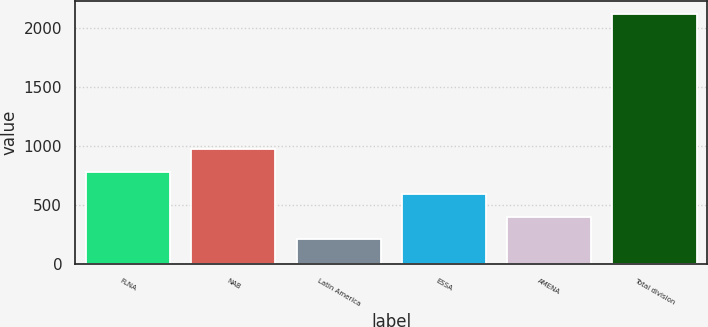Convert chart. <chart><loc_0><loc_0><loc_500><loc_500><bar_chart><fcel>FLNA<fcel>NAB<fcel>Latin America<fcel>ESSA<fcel>AMENA<fcel>Total division<nl><fcel>783.7<fcel>974.6<fcel>211<fcel>592.8<fcel>401.9<fcel>2120<nl></chart> 